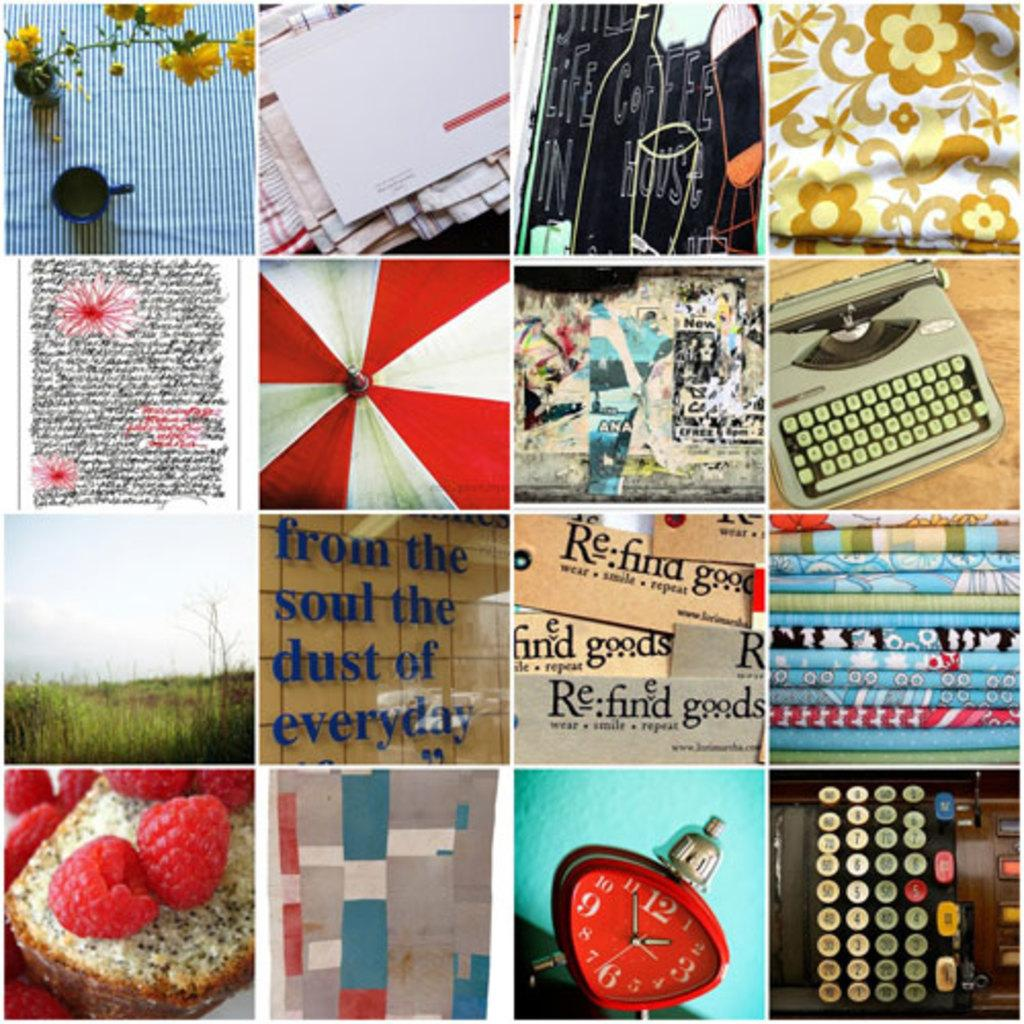Provide a one-sentence caption for the provided image. Collage of photos with one saying "Refind Goods". 